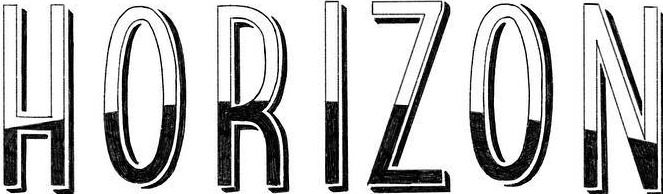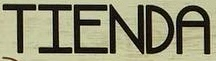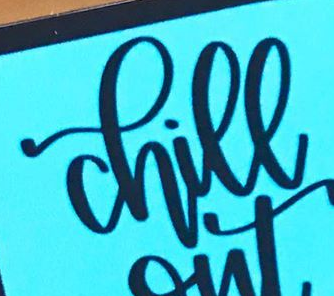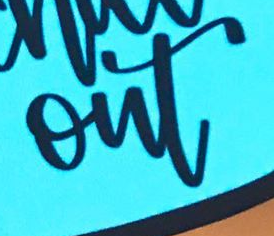What words can you see in these images in sequence, separated by a semicolon? HORIZON; TIENDA; chill; out 